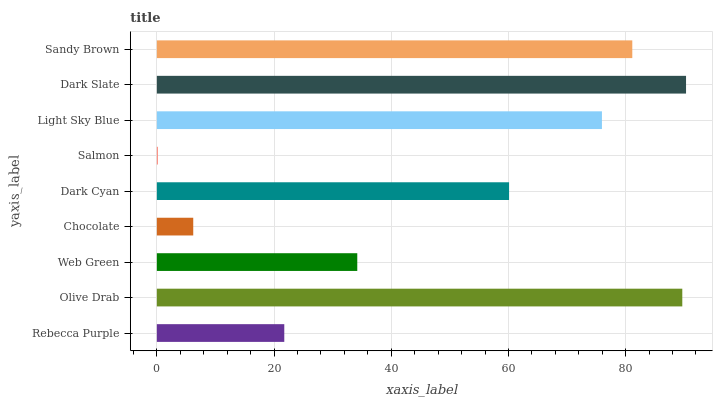Is Salmon the minimum?
Answer yes or no. Yes. Is Dark Slate the maximum?
Answer yes or no. Yes. Is Olive Drab the minimum?
Answer yes or no. No. Is Olive Drab the maximum?
Answer yes or no. No. Is Olive Drab greater than Rebecca Purple?
Answer yes or no. Yes. Is Rebecca Purple less than Olive Drab?
Answer yes or no. Yes. Is Rebecca Purple greater than Olive Drab?
Answer yes or no. No. Is Olive Drab less than Rebecca Purple?
Answer yes or no. No. Is Dark Cyan the high median?
Answer yes or no. Yes. Is Dark Cyan the low median?
Answer yes or no. Yes. Is Olive Drab the high median?
Answer yes or no. No. Is Olive Drab the low median?
Answer yes or no. No. 